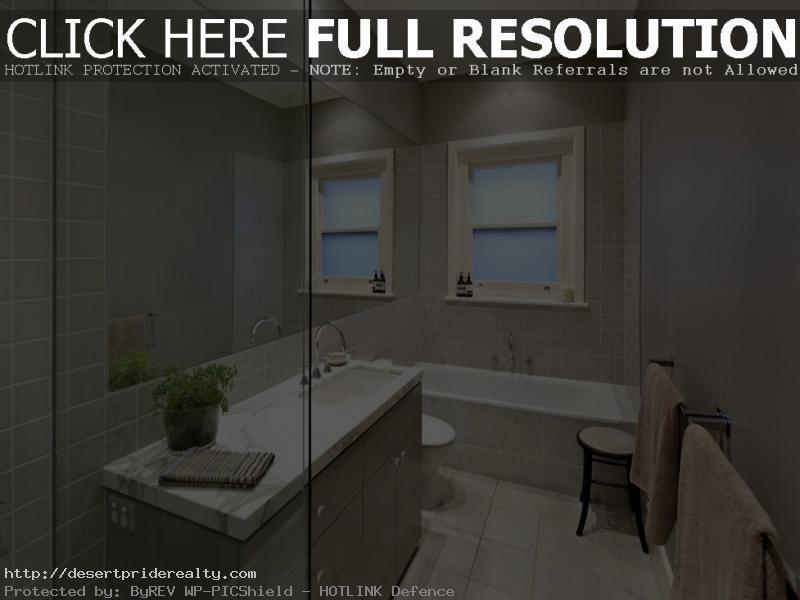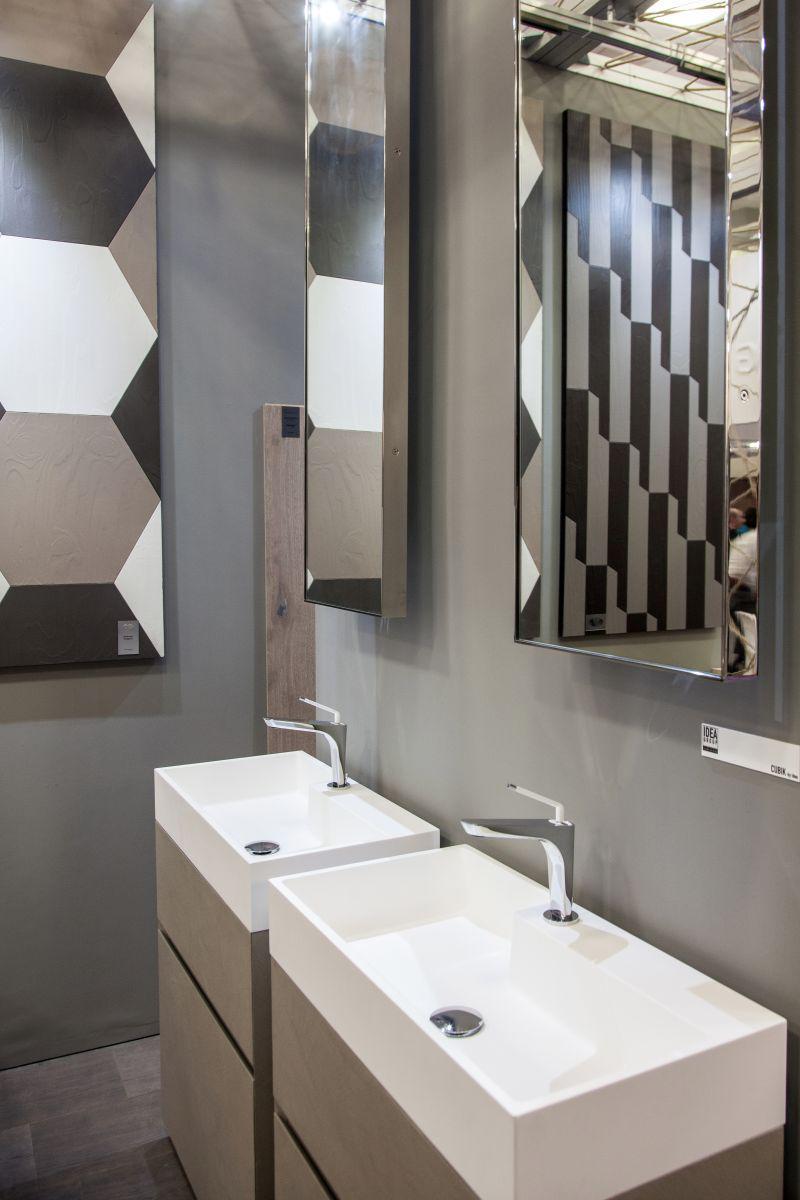The first image is the image on the left, the second image is the image on the right. For the images shown, is this caption "In one image, matching rectangular white sinks are placed on top of side-by-side vanities." true? Answer yes or no. Yes. 